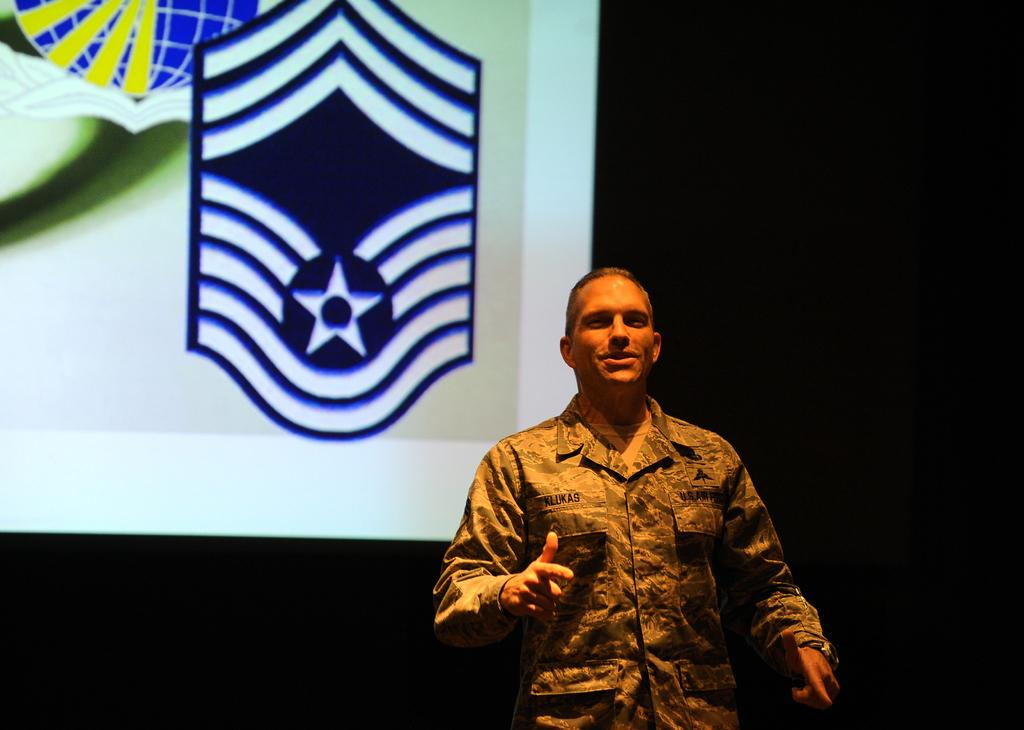What is the main subject of the image? There is a person or man standing in the image. Can you describe the background of the image? There is a screen visible in the background of the image. What type of celery is being used to hear the person speak in the image? There is no celery present in the image, and it is not being used to hear the person speak. 